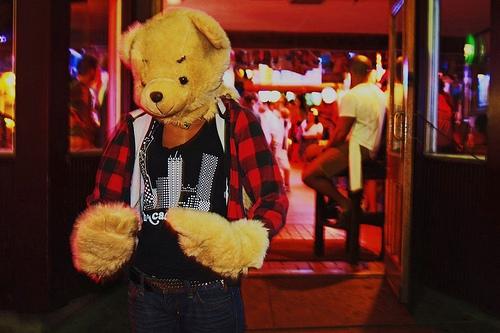What is this person dressed as?
Quick response, please. Bear. How many teddy bears are brown?
Concise answer only. 1. Where are these dolls sold?
Concise answer only. Store. Is the large bear a chairman?
Give a very brief answer. No. How many pink bears in picture?
Concise answer only. 0. Is this person a woman?
Write a very short answer. Yes. How many bears are there?
Be succinct. 1. What is around the bears neck?
Answer briefly. Necklace. Why does this bear look scary?
Quick response, please. Creepy. What color plaid shirt is this person wearing?
Concise answer only. Red and black. What would the bear's job title be?
Write a very short answer. Bouncer. How many bears are facing the camera?
Quick response, please. 1. Is this a guy or a girl?
Be succinct. Guy. What is this in the picture?
Concise answer only. Bear. 